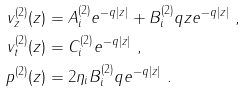<formula> <loc_0><loc_0><loc_500><loc_500>v _ { z } ^ { ( 2 ) } ( z ) & = A _ { i } ^ { ( 2 ) } e ^ { - q | z | } + B _ { i } ^ { ( 2 ) } q z e ^ { - q | z | } \ , \\ v _ { t } ^ { ( 2 ) } ( z ) & = C _ { i } ^ { ( 2 ) } e ^ { - q | z | } \ , \\ p ^ { ( 2 ) } ( z ) & = 2 \eta _ { i } B _ { i } ^ { ( 2 ) } q e ^ { - q | z | } \ .</formula> 